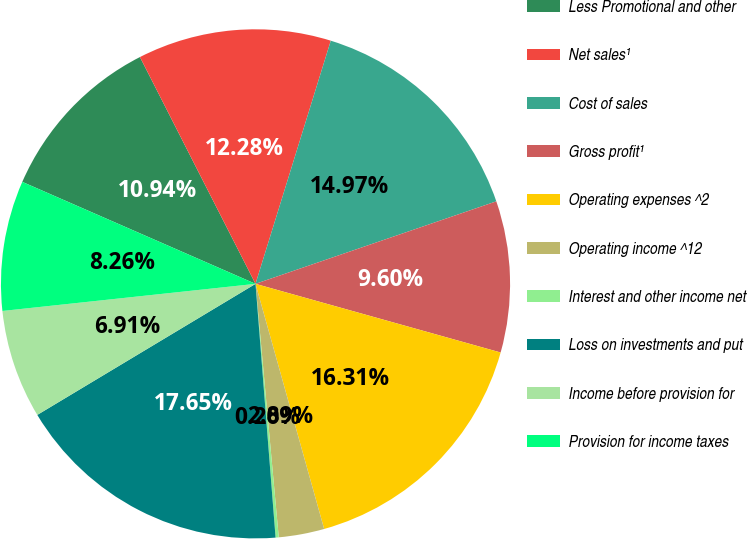Convert chart to OTSL. <chart><loc_0><loc_0><loc_500><loc_500><pie_chart><fcel>Less Promotional and other<fcel>Net sales¹<fcel>Cost of sales<fcel>Gross profit¹<fcel>Operating expenses ^2<fcel>Operating income ^12<fcel>Interest and other income net<fcel>Loss on investments and put<fcel>Income before provision for<fcel>Provision for income taxes<nl><fcel>10.94%<fcel>12.28%<fcel>14.97%<fcel>9.6%<fcel>16.31%<fcel>2.89%<fcel>0.2%<fcel>17.65%<fcel>6.91%<fcel>8.26%<nl></chart> 